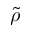<formula> <loc_0><loc_0><loc_500><loc_500>\widetilde { \rho }</formula> 